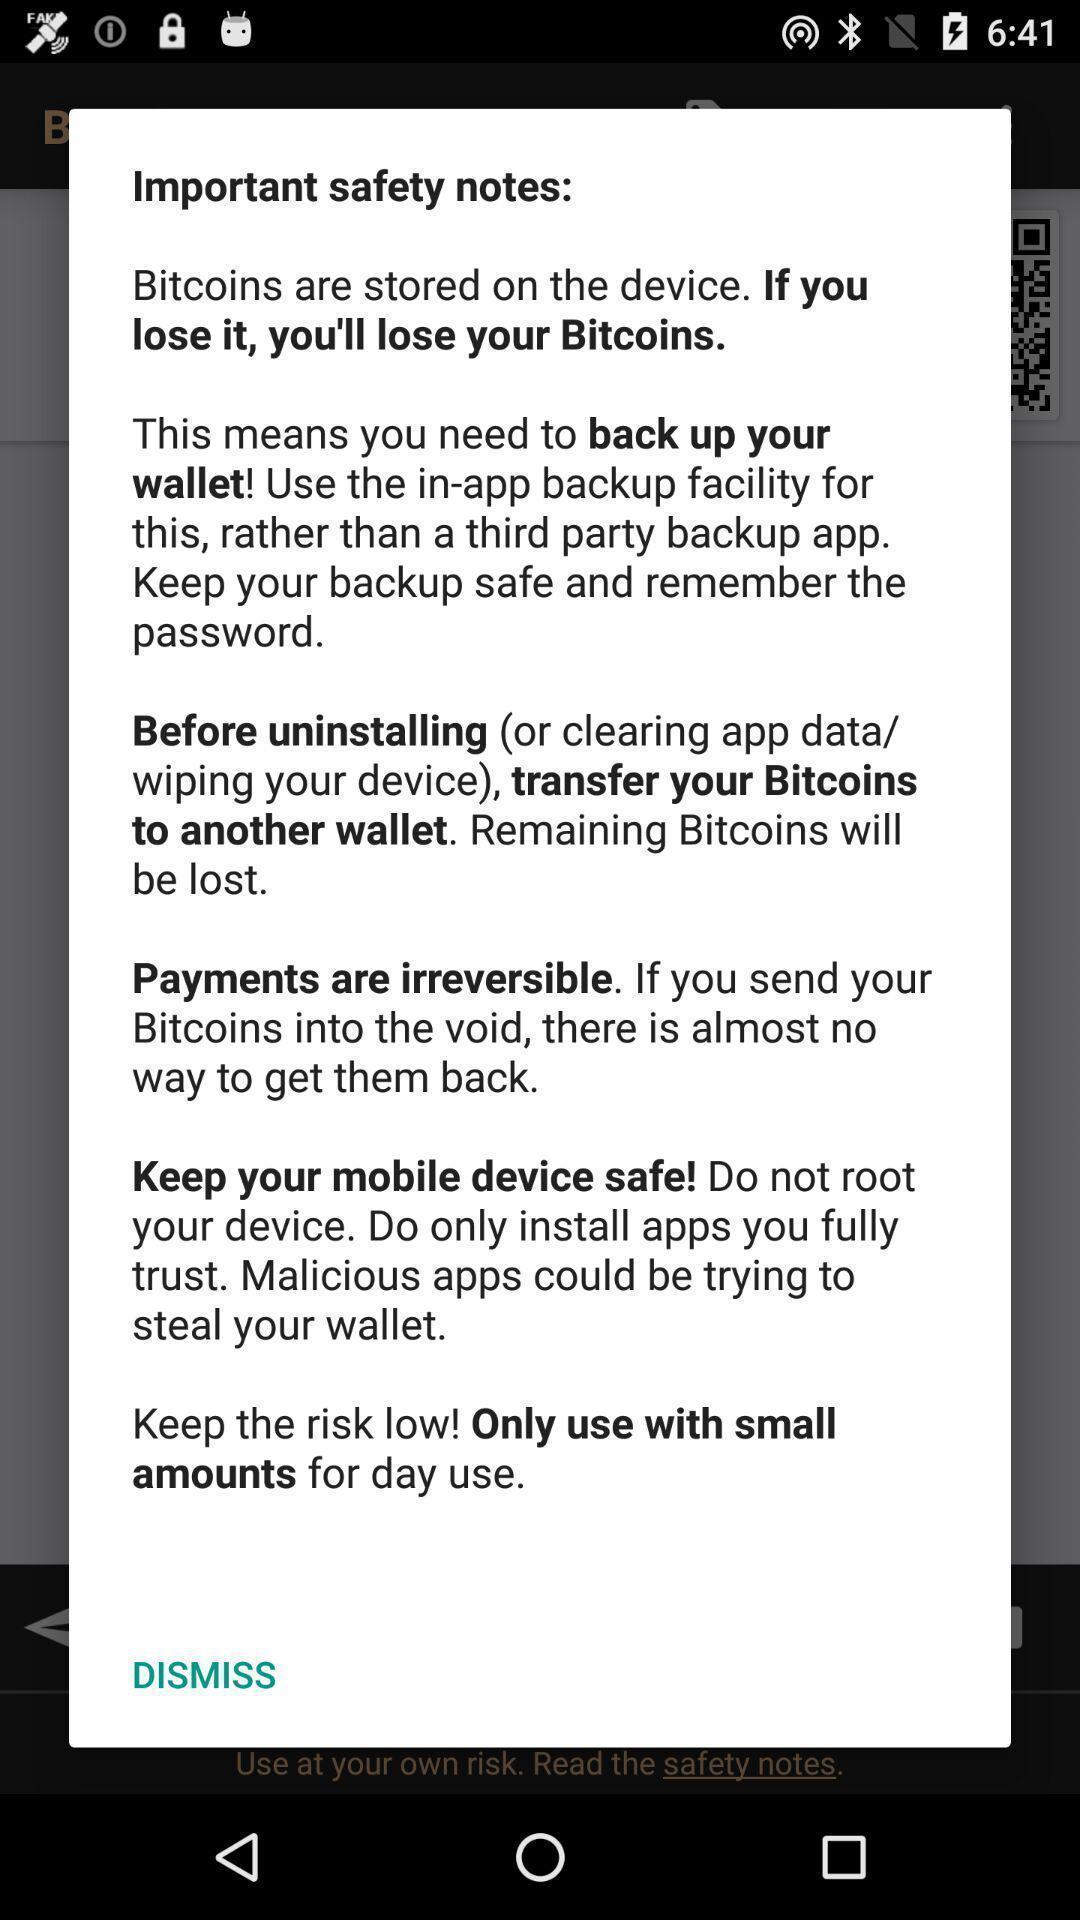Explain what's happening in this screen capture. Pop-up showing important safety notes. 